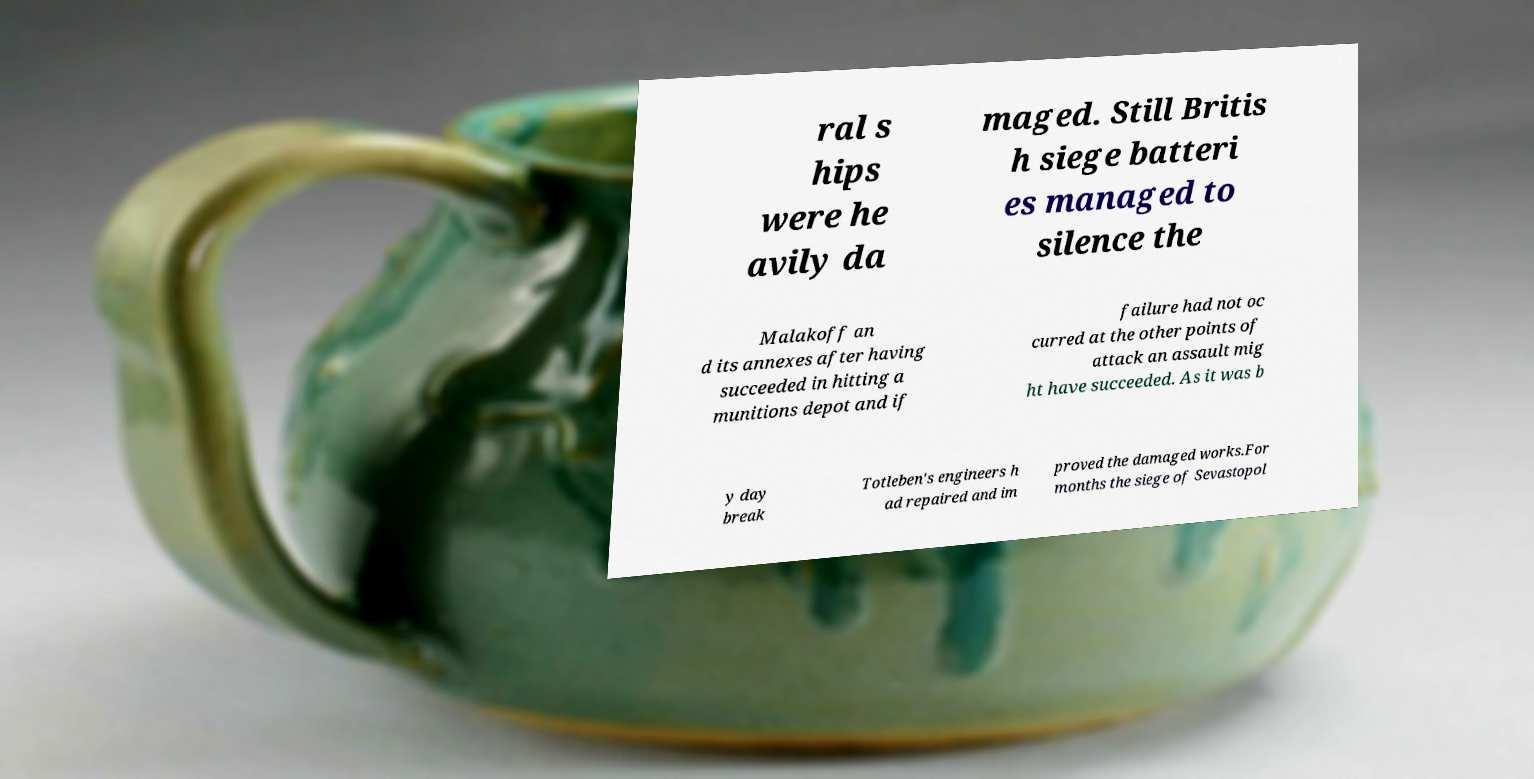Can you read and provide the text displayed in the image?This photo seems to have some interesting text. Can you extract and type it out for me? ral s hips were he avily da maged. Still Britis h siege batteri es managed to silence the Malakoff an d its annexes after having succeeded in hitting a munitions depot and if failure had not oc curred at the other points of attack an assault mig ht have succeeded. As it was b y day break Totleben's engineers h ad repaired and im proved the damaged works.For months the siege of Sevastopol 